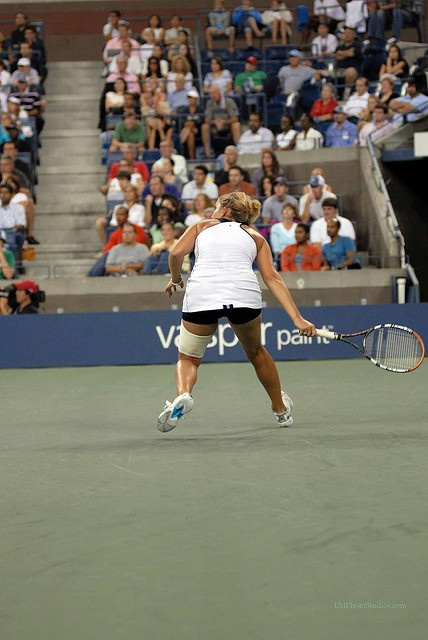Describe the objects in this image and their specific colors. I can see people in gray, black, maroon, and darkgray tones, people in gray, white, black, and maroon tones, tennis racket in gray, darkgray, darkblue, and black tones, people in gray, darkgray, and tan tones, and people in gray, brown, and maroon tones in this image. 